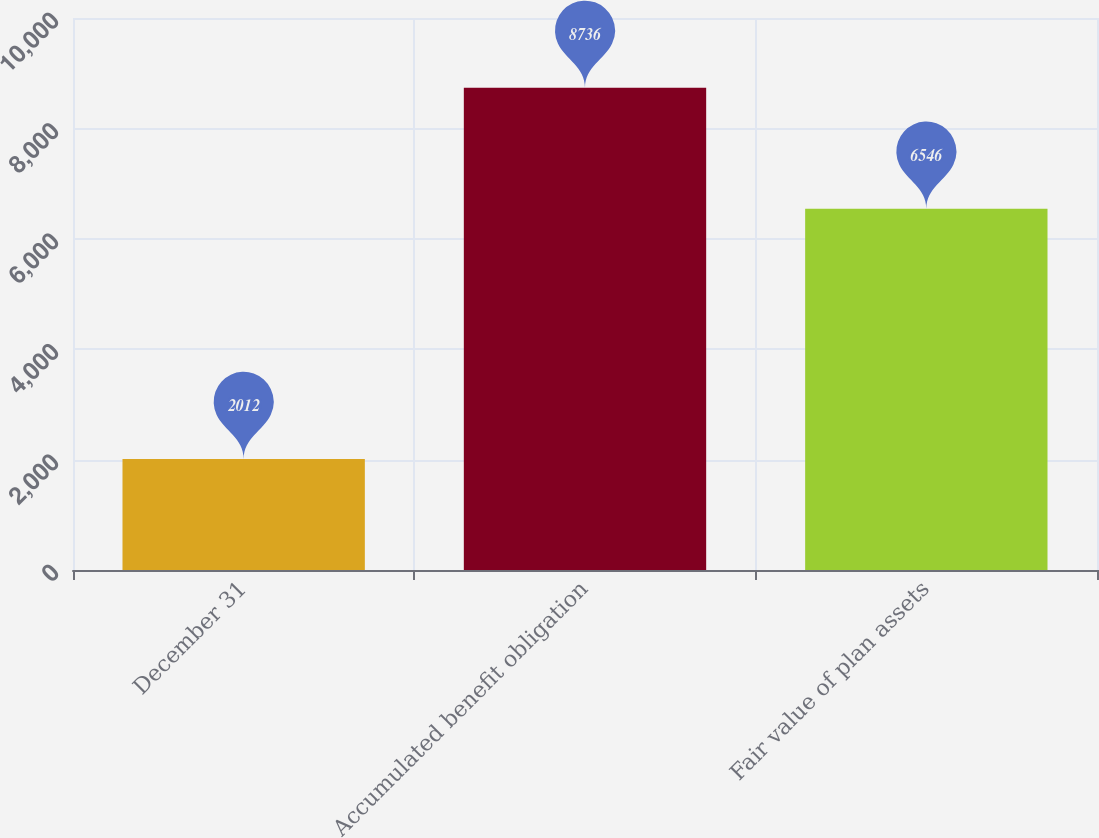Convert chart. <chart><loc_0><loc_0><loc_500><loc_500><bar_chart><fcel>December 31<fcel>Accumulated benefit obligation<fcel>Fair value of plan assets<nl><fcel>2012<fcel>8736<fcel>6546<nl></chart> 